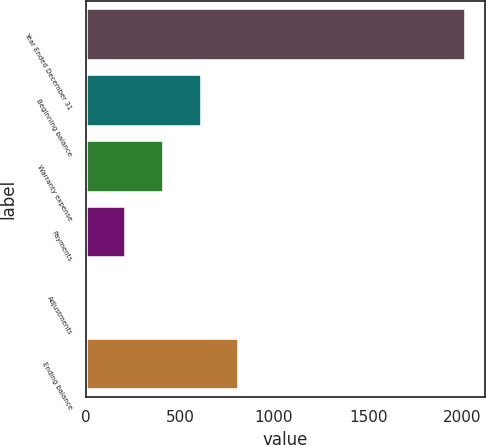Convert chart to OTSL. <chart><loc_0><loc_0><loc_500><loc_500><bar_chart><fcel>Year Ended December 31<fcel>Beginning balance<fcel>Warranty expense<fcel>Payments<fcel>Adjustments<fcel>Ending balance<nl><fcel>2018<fcel>615.2<fcel>414.8<fcel>214.4<fcel>14<fcel>815.6<nl></chart> 